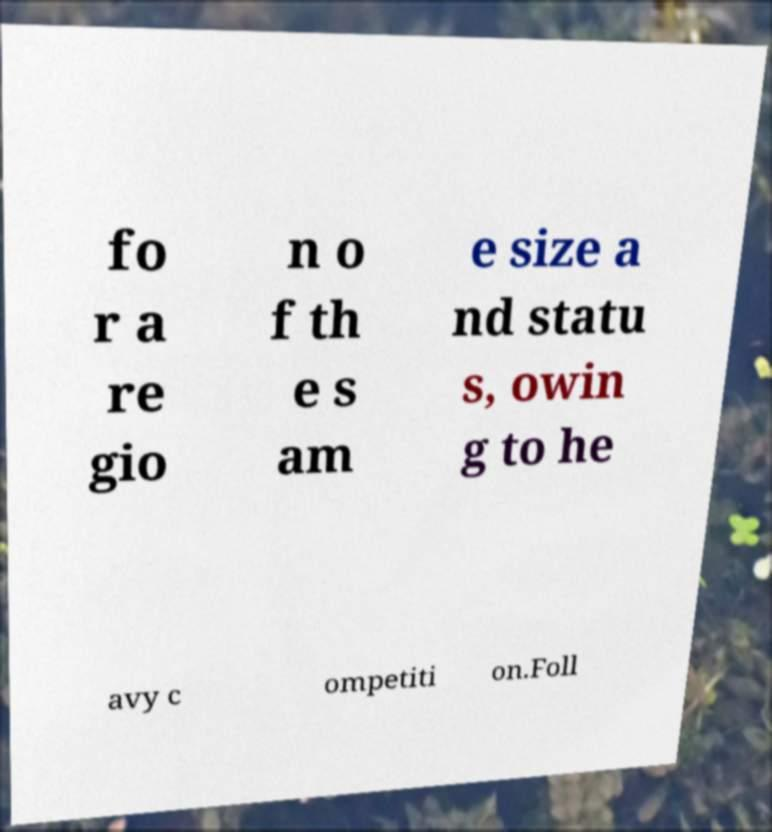Could you extract and type out the text from this image? fo r a re gio n o f th e s am e size a nd statu s, owin g to he avy c ompetiti on.Foll 